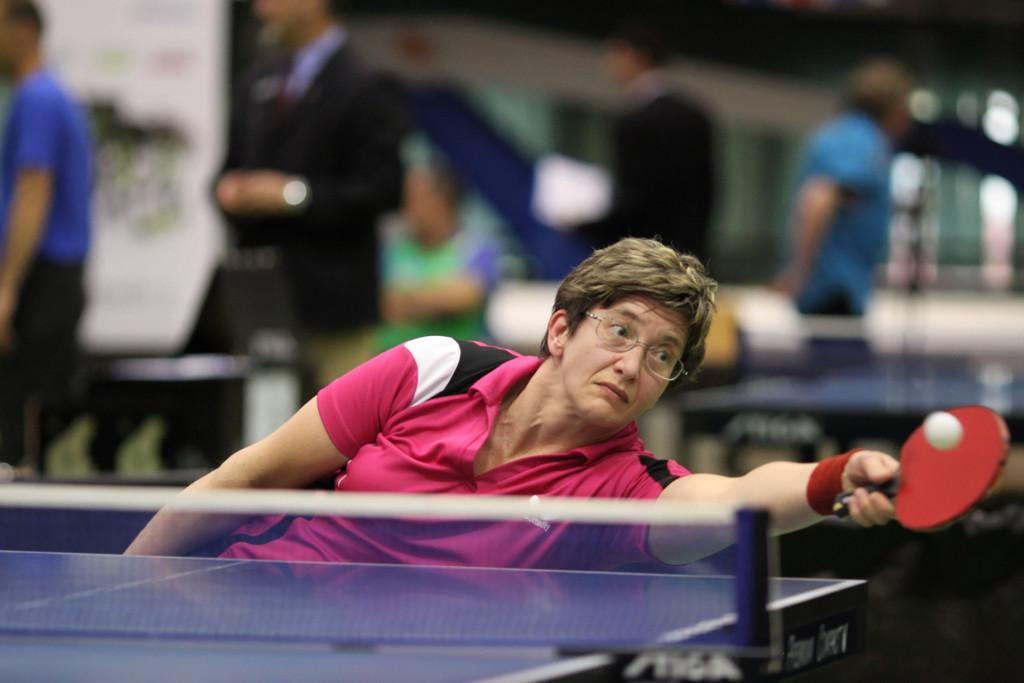What activity is the person in the image engaged in? The person is playing table tennis in the image. Can you describe the people in the background of the image? There are people standing in the background of the image. How is the background of the image depicted? The background is blurred. What type of bed is visible in the image? There is no bed present in the image. What decisions is the committee making in the image? There is no committee present in the image. 